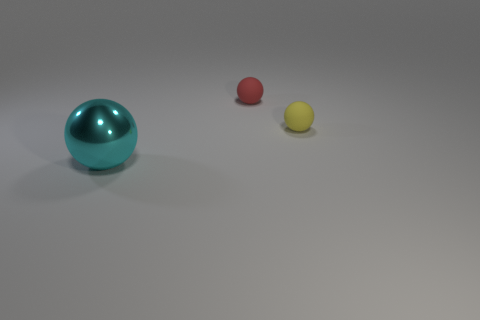What number of tiny yellow cylinders are there?
Provide a succinct answer. 0. Are there any other things that are the same size as the red ball?
Your response must be concise. Yes. Is the tiny red ball made of the same material as the cyan object?
Your response must be concise. No. There is a thing that is behind the small yellow thing; does it have the same size as the sphere that is in front of the yellow matte ball?
Your response must be concise. No. Is the number of tiny brown cylinders less than the number of metallic objects?
Offer a terse response. Yes. What number of matte objects are either large things or small cubes?
Provide a succinct answer. 0. There is a matte ball that is to the right of the small red ball; is there a small yellow rubber thing that is in front of it?
Keep it short and to the point. No. Does the thing behind the small yellow rubber thing have the same material as the cyan object?
Offer a terse response. No. What number of other objects are there of the same color as the large shiny thing?
Ensure brevity in your answer.  0. There is a matte thing that is in front of the small matte thing that is on the left side of the tiny yellow matte sphere; how big is it?
Give a very brief answer. Small. 